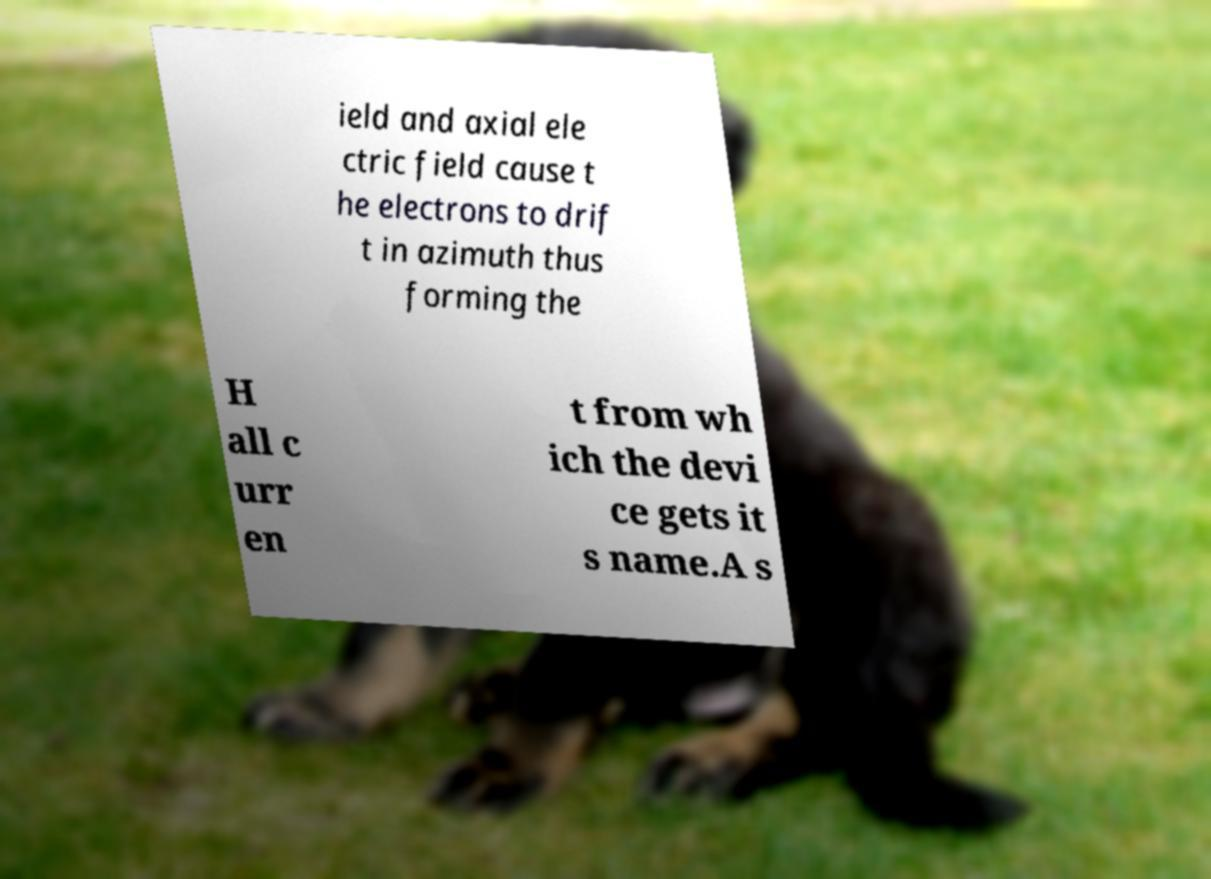I need the written content from this picture converted into text. Can you do that? ield and axial ele ctric field cause t he electrons to drif t in azimuth thus forming the H all c urr en t from wh ich the devi ce gets it s name.A s 